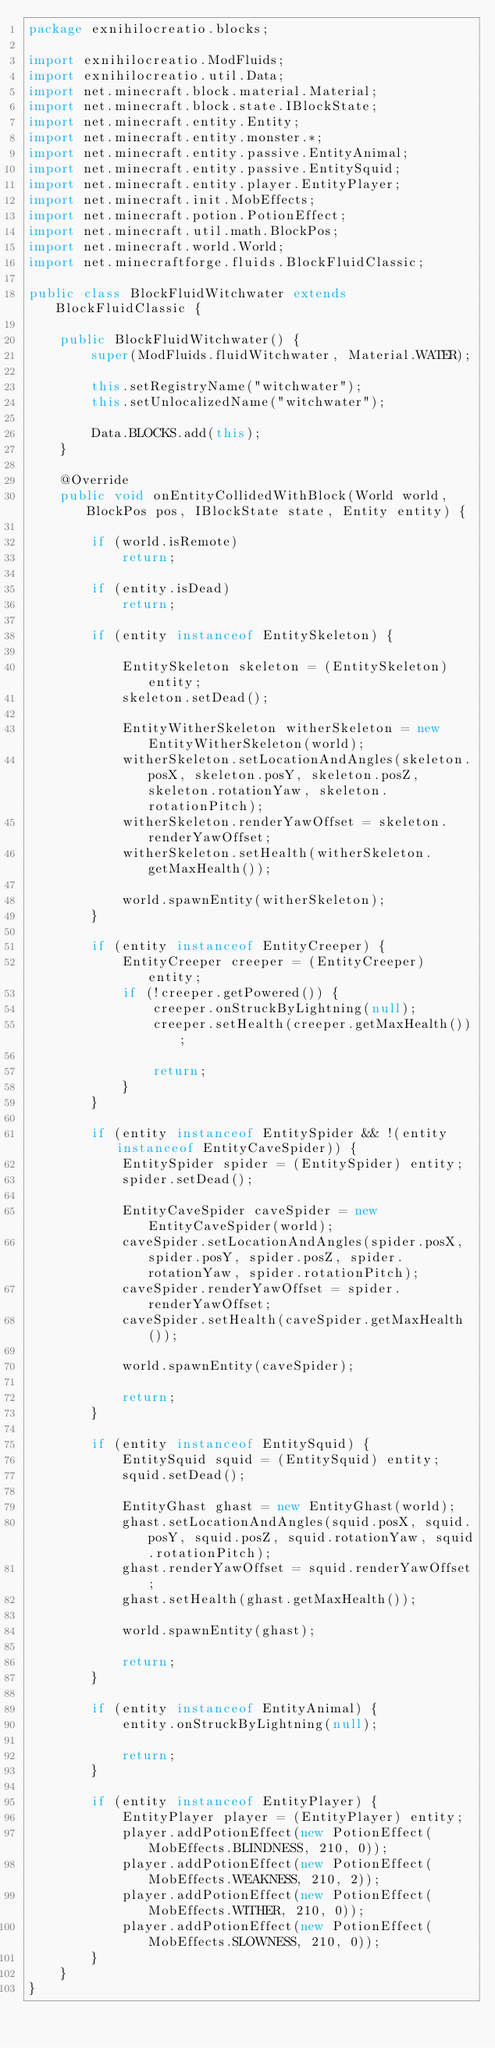Convert code to text. <code><loc_0><loc_0><loc_500><loc_500><_Java_>package exnihilocreatio.blocks;

import exnihilocreatio.ModFluids;
import exnihilocreatio.util.Data;
import net.minecraft.block.material.Material;
import net.minecraft.block.state.IBlockState;
import net.minecraft.entity.Entity;
import net.minecraft.entity.monster.*;
import net.minecraft.entity.passive.EntityAnimal;
import net.minecraft.entity.passive.EntitySquid;
import net.minecraft.entity.player.EntityPlayer;
import net.minecraft.init.MobEffects;
import net.minecraft.potion.PotionEffect;
import net.minecraft.util.math.BlockPos;
import net.minecraft.world.World;
import net.minecraftforge.fluids.BlockFluidClassic;

public class BlockFluidWitchwater extends BlockFluidClassic {

    public BlockFluidWitchwater() {
        super(ModFluids.fluidWitchwater, Material.WATER);

        this.setRegistryName("witchwater");
        this.setUnlocalizedName("witchwater");

        Data.BLOCKS.add(this);
    }

    @Override
    public void onEntityCollidedWithBlock(World world, BlockPos pos, IBlockState state, Entity entity) {

        if (world.isRemote)
            return;

        if (entity.isDead)
            return;

        if (entity instanceof EntitySkeleton) {

            EntitySkeleton skeleton = (EntitySkeleton) entity;
            skeleton.setDead();

            EntityWitherSkeleton witherSkeleton = new EntityWitherSkeleton(world);
            witherSkeleton.setLocationAndAngles(skeleton.posX, skeleton.posY, skeleton.posZ, skeleton.rotationYaw, skeleton.rotationPitch);
            witherSkeleton.renderYawOffset = skeleton.renderYawOffset;
            witherSkeleton.setHealth(witherSkeleton.getMaxHealth());

            world.spawnEntity(witherSkeleton);
        }

        if (entity instanceof EntityCreeper) {
            EntityCreeper creeper = (EntityCreeper) entity;
            if (!creeper.getPowered()) {
                creeper.onStruckByLightning(null);
                creeper.setHealth(creeper.getMaxHealth());

                return;
            }
        }

        if (entity instanceof EntitySpider && !(entity instanceof EntityCaveSpider)) {
            EntitySpider spider = (EntitySpider) entity;
            spider.setDead();

            EntityCaveSpider caveSpider = new EntityCaveSpider(world);
            caveSpider.setLocationAndAngles(spider.posX, spider.posY, spider.posZ, spider.rotationYaw, spider.rotationPitch);
            caveSpider.renderYawOffset = spider.renderYawOffset;
            caveSpider.setHealth(caveSpider.getMaxHealth());

            world.spawnEntity(caveSpider);

            return;
        }

        if (entity instanceof EntitySquid) {
            EntitySquid squid = (EntitySquid) entity;
            squid.setDead();

            EntityGhast ghast = new EntityGhast(world);
            ghast.setLocationAndAngles(squid.posX, squid.posY, squid.posZ, squid.rotationYaw, squid.rotationPitch);
            ghast.renderYawOffset = squid.renderYawOffset;
            ghast.setHealth(ghast.getMaxHealth());

            world.spawnEntity(ghast);

            return;
        }

        if (entity instanceof EntityAnimal) {
            entity.onStruckByLightning(null);

            return;
        }

        if (entity instanceof EntityPlayer) {
            EntityPlayer player = (EntityPlayer) entity;
            player.addPotionEffect(new PotionEffect(MobEffects.BLINDNESS, 210, 0));
            player.addPotionEffect(new PotionEffect(MobEffects.WEAKNESS, 210, 2));
            player.addPotionEffect(new PotionEffect(MobEffects.WITHER, 210, 0));
            player.addPotionEffect(new PotionEffect(MobEffects.SLOWNESS, 210, 0));
        }
    }
}
</code> 